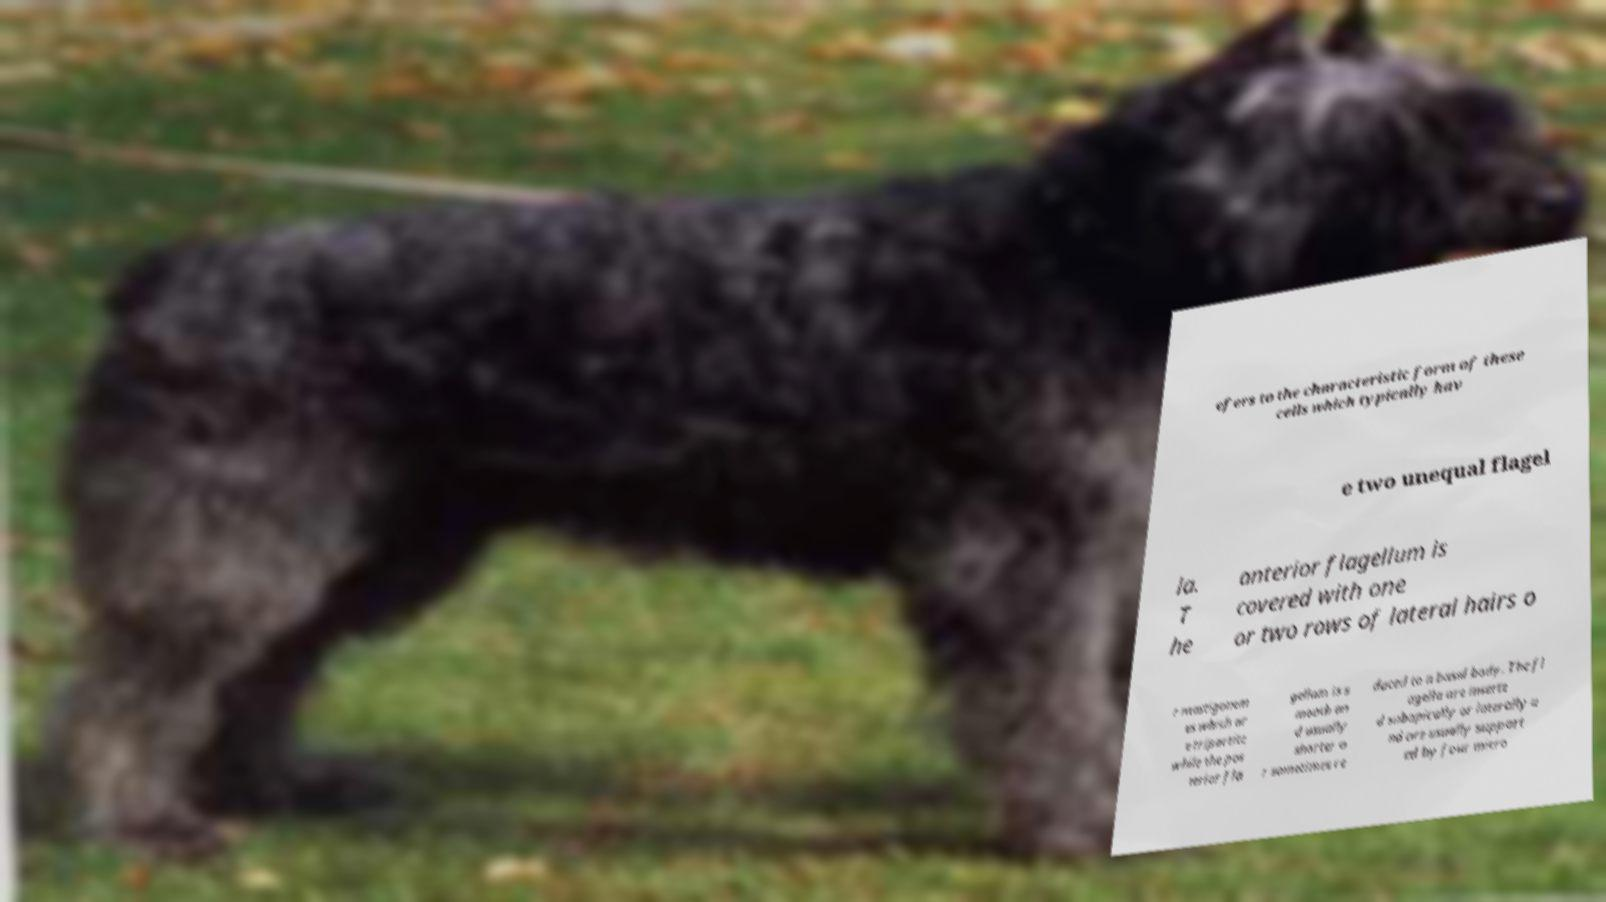Can you read and provide the text displayed in the image?This photo seems to have some interesting text. Can you extract and type it out for me? efers to the characteristic form of these cells which typically hav e two unequal flagel la. T he anterior flagellum is covered with one or two rows of lateral hairs o r mastigonem es which ar e tripartite while the pos terior fla gellum is s mooth an d usually shorter o r sometimes re duced to a basal body. The fl agella are inserte d subapically or laterally a nd are usually support ed by four micro 